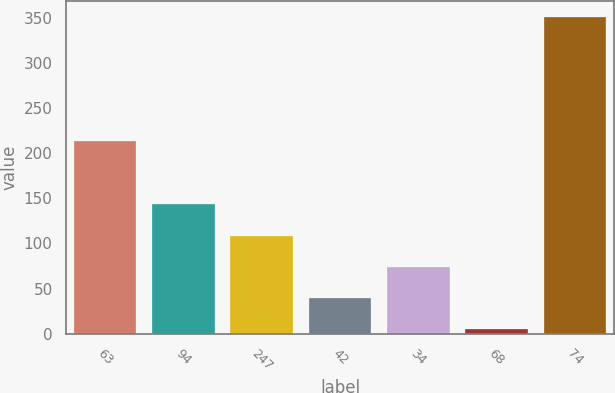Convert chart to OTSL. <chart><loc_0><loc_0><loc_500><loc_500><bar_chart><fcel>63<fcel>94<fcel>247<fcel>42<fcel>34<fcel>68<fcel>74<nl><fcel>213.2<fcel>143.18<fcel>108.61<fcel>39.47<fcel>74.04<fcel>4.9<fcel>350.6<nl></chart> 